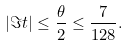<formula> <loc_0><loc_0><loc_500><loc_500>| \Im t | \leq \frac { \theta } { 2 } \leq \frac { 7 } { 1 2 8 } .</formula> 